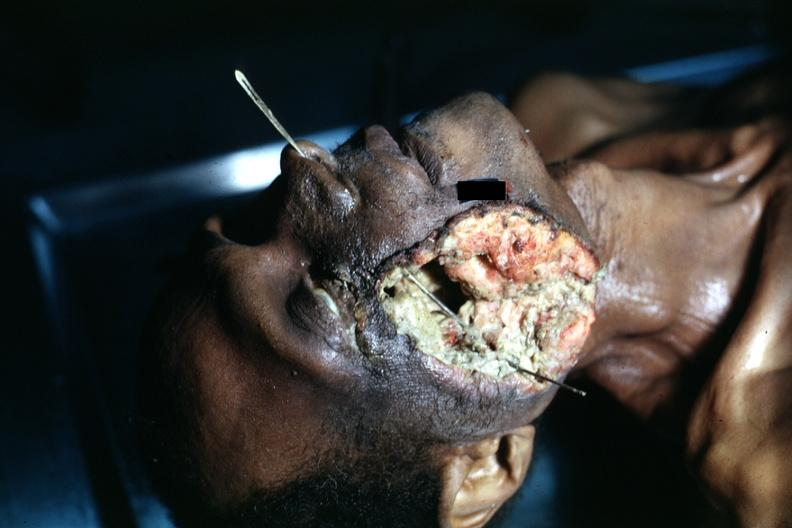how does this image show view of head?
Answer the question using a single word or phrase. With huge ulcerated mass where tumor grew to outside 